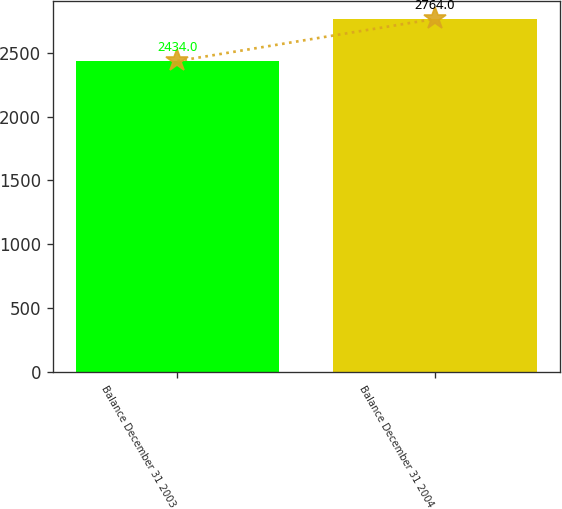Convert chart. <chart><loc_0><loc_0><loc_500><loc_500><bar_chart><fcel>Balance December 31 2003<fcel>Balance December 31 2004<nl><fcel>2434<fcel>2764<nl></chart> 